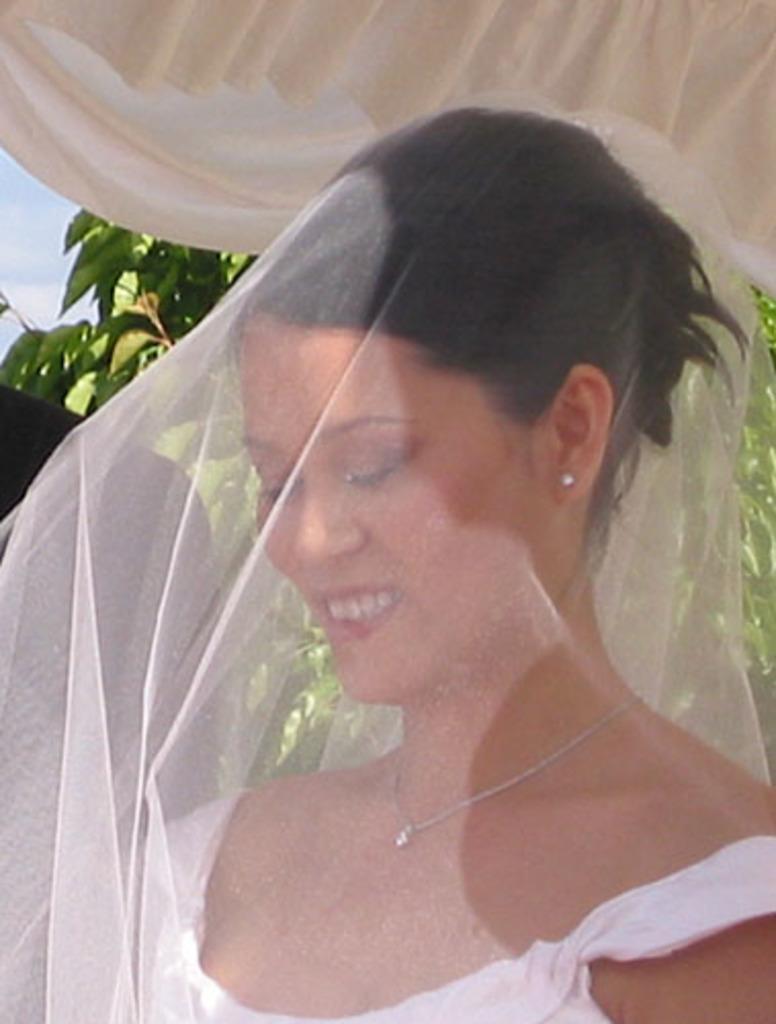Could you give a brief overview of what you see in this image? In this image we can see a lady. And the lady is covered by a net. At the top there is a cloth. In the back there are branches with leaves. Also there is sky. 